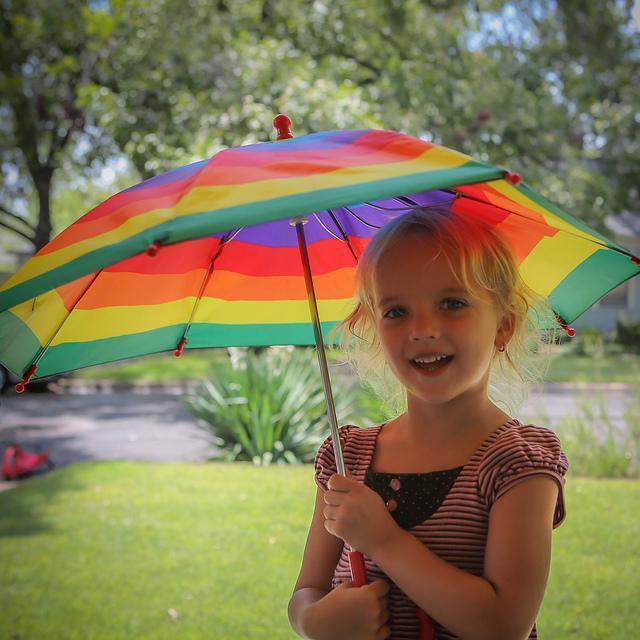How many big chairs are in the image?
Give a very brief answer. 0. 